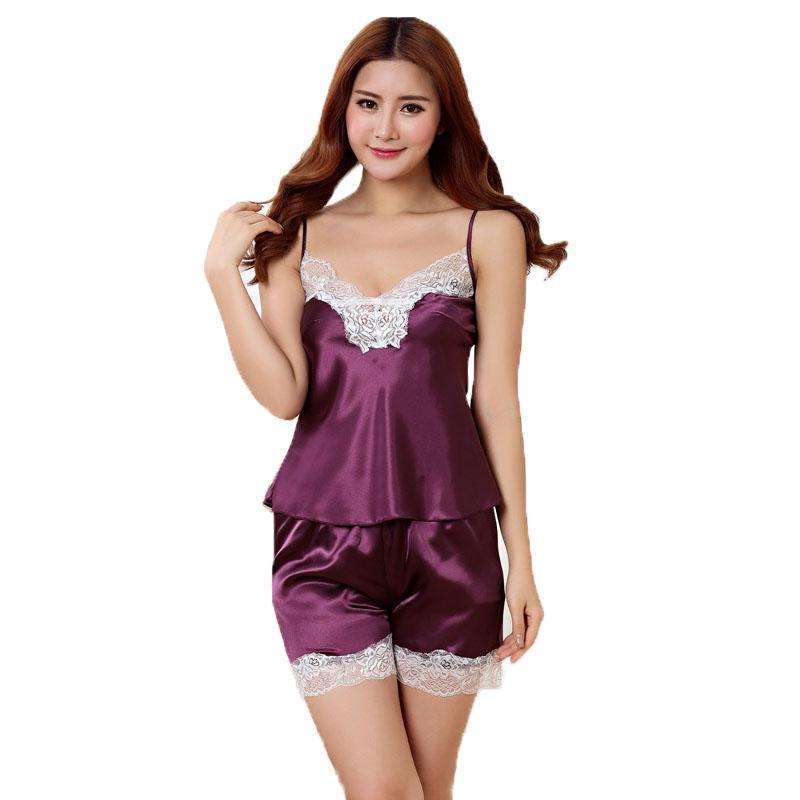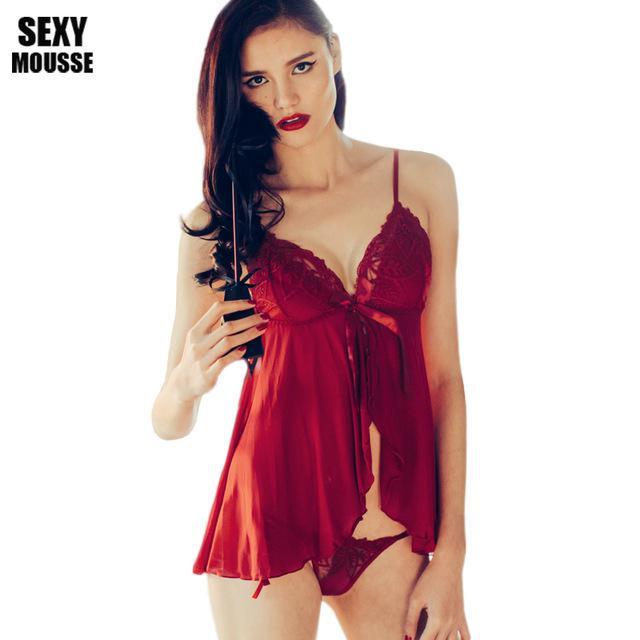The first image is the image on the left, the second image is the image on the right. For the images displayed, is the sentence "there is a silky cami set with white lace on the chest" factually correct? Answer yes or no. Yes. 